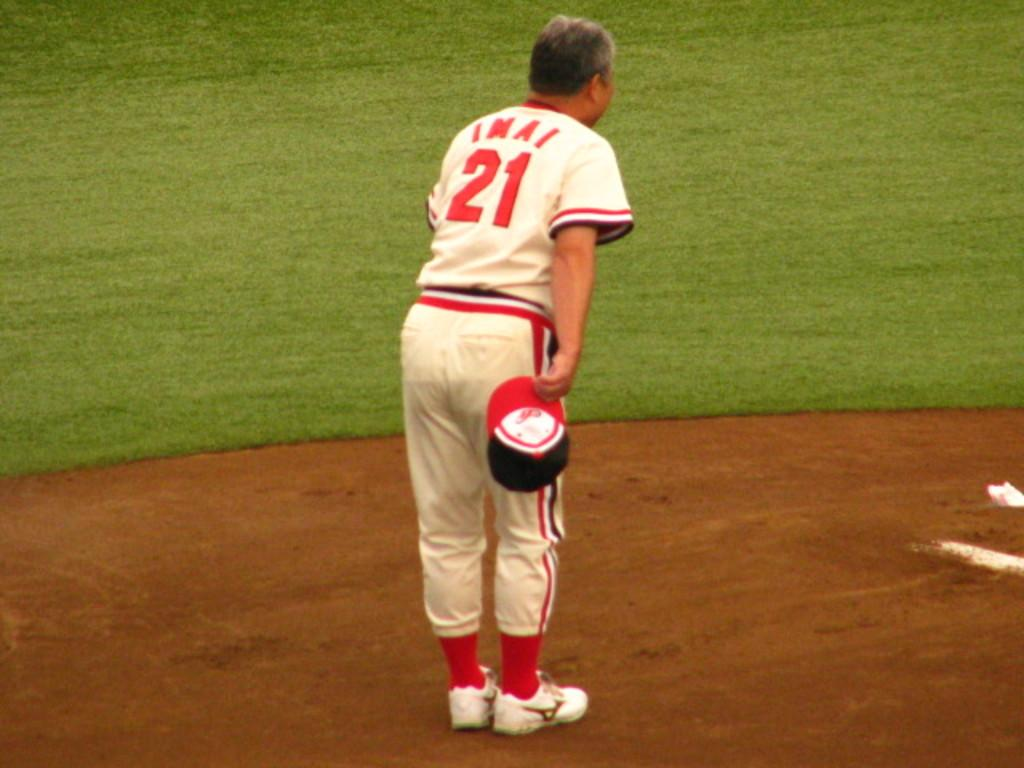<image>
Describe the image concisely. A baseball player with a jersey that says IMAI and the number 21. 